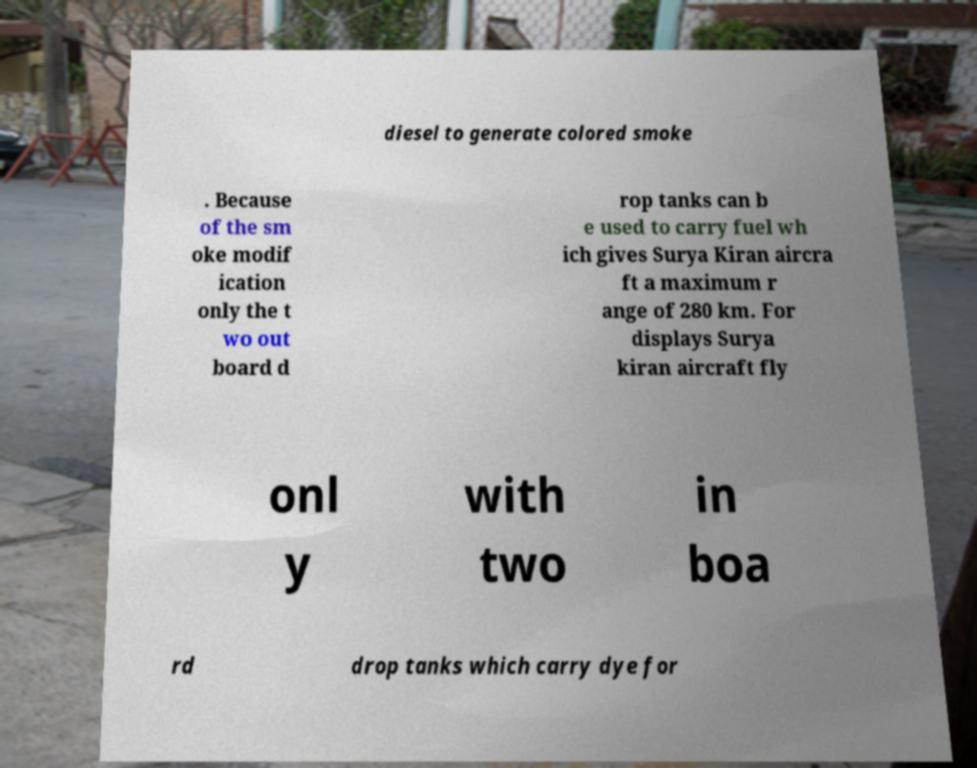Can you accurately transcribe the text from the provided image for me? diesel to generate colored smoke . Because of the sm oke modif ication only the t wo out board d rop tanks can b e used to carry fuel wh ich gives Surya Kiran aircra ft a maximum r ange of 280 km. For displays Surya kiran aircraft fly onl y with two in boa rd drop tanks which carry dye for 